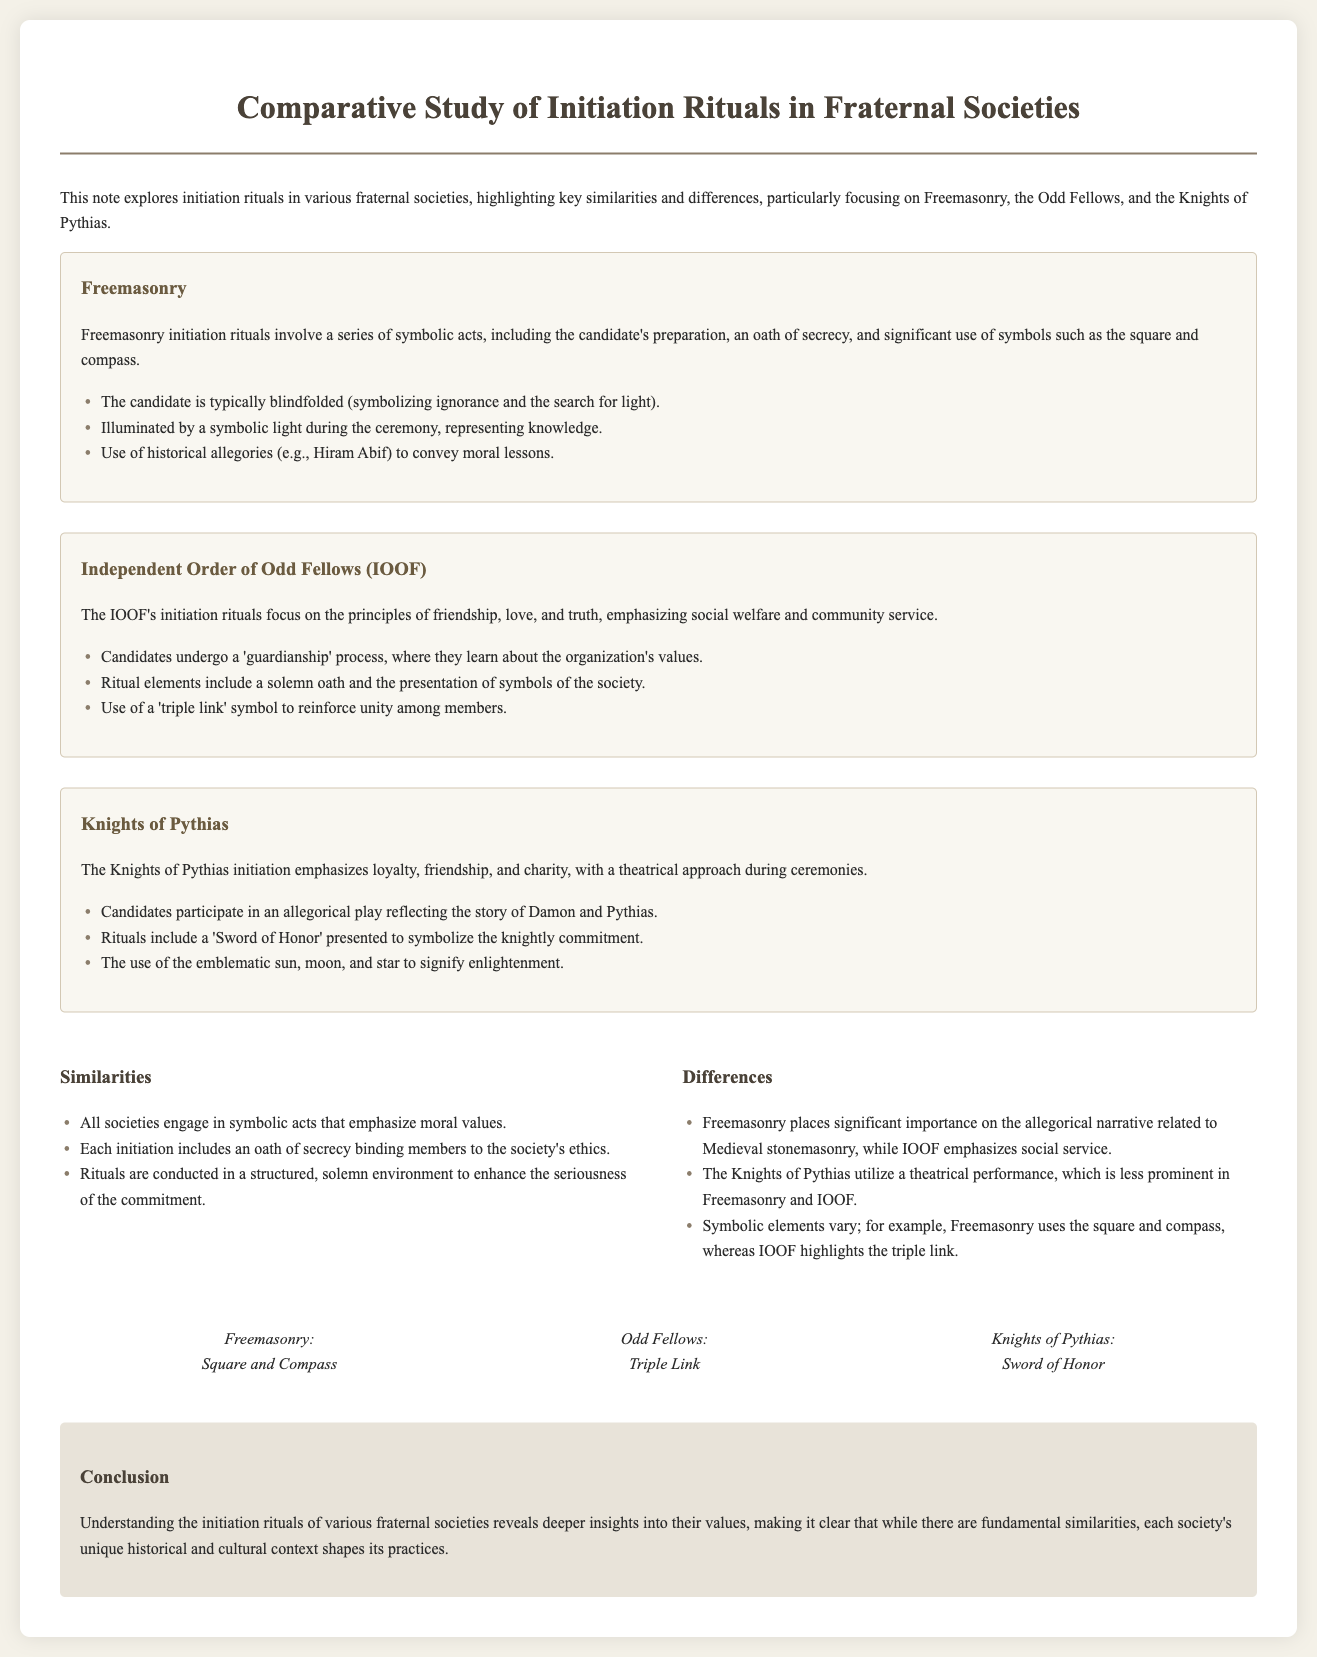What are the names of the fraternal societies discussed? The document specifically mentions Freemasonry, the Independent Order of Odd Fellows (IOOF), and the Knights of Pythias.
Answer: Freemasonry, IOOF, Knights of Pythias What symbolic act is common to all initiation rituals mentioned? Each society engages in symbolic acts that emphasize moral values as a key component of their initiation rituals.
Answer: Symbolic acts What unique symbol is associated with Freemasonry? The document states that Freemasonry uses the square and compass as its symbolic element during initiation rituals.
Answer: Square and Compass What is the emphasis of the Knights of Pythias’ initiation rituals? The initiation rituals of the Knights of Pythias emphasize loyalty, friendship, and charity, based on the information provided.
Answer: Loyalty, friendship, charity How do the Independent Order of Odd Fellows’ rituals reinforce its values? The IOOF emphasizes its values through a guardianship process during initiation, where candidates learn about the organization's principles.
Answer: Guardianship process What is the primary focus of the Independent Order of Odd Fellows? The document highlights that the focus of the Independent Order of Odd Fellows' initiation rituals is on social welfare and community service.
Answer: Social welfare and community service What narrative framework does Freemasonry utilize in its rituals? Freemasonry utilizes a historical allegory related to Medieval stonemasonry, specifically mentioning the figure of Hiram Abif.
Answer: Hiram Abif What theatrical element is unique to the Knights of Pythias? The Knights of Pythias incorporate a theatrical play reflecting the story of Damon and Pythias, which characterizes their initiation process.
Answer: Theatrical play What is the concluding statement regarding the rituals? The conclusion of the document emphasizes that each society’s unique historical and cultural context shapes its initiation practices, despite their fundamental similarities.
Answer: Unique historical and cultural context 